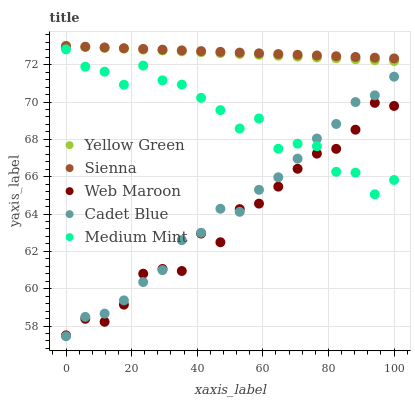Does Web Maroon have the minimum area under the curve?
Answer yes or no. Yes. Does Sienna have the maximum area under the curve?
Answer yes or no. Yes. Does Medium Mint have the minimum area under the curve?
Answer yes or no. No. Does Medium Mint have the maximum area under the curve?
Answer yes or no. No. Is Sienna the smoothest?
Answer yes or no. Yes. Is Medium Mint the roughest?
Answer yes or no. Yes. Is Cadet Blue the smoothest?
Answer yes or no. No. Is Cadet Blue the roughest?
Answer yes or no. No. Does Cadet Blue have the lowest value?
Answer yes or no. Yes. Does Medium Mint have the lowest value?
Answer yes or no. No. Does Yellow Green have the highest value?
Answer yes or no. Yes. Does Medium Mint have the highest value?
Answer yes or no. No. Is Medium Mint less than Sienna?
Answer yes or no. Yes. Is Yellow Green greater than Web Maroon?
Answer yes or no. Yes. Does Web Maroon intersect Cadet Blue?
Answer yes or no. Yes. Is Web Maroon less than Cadet Blue?
Answer yes or no. No. Is Web Maroon greater than Cadet Blue?
Answer yes or no. No. Does Medium Mint intersect Sienna?
Answer yes or no. No. 